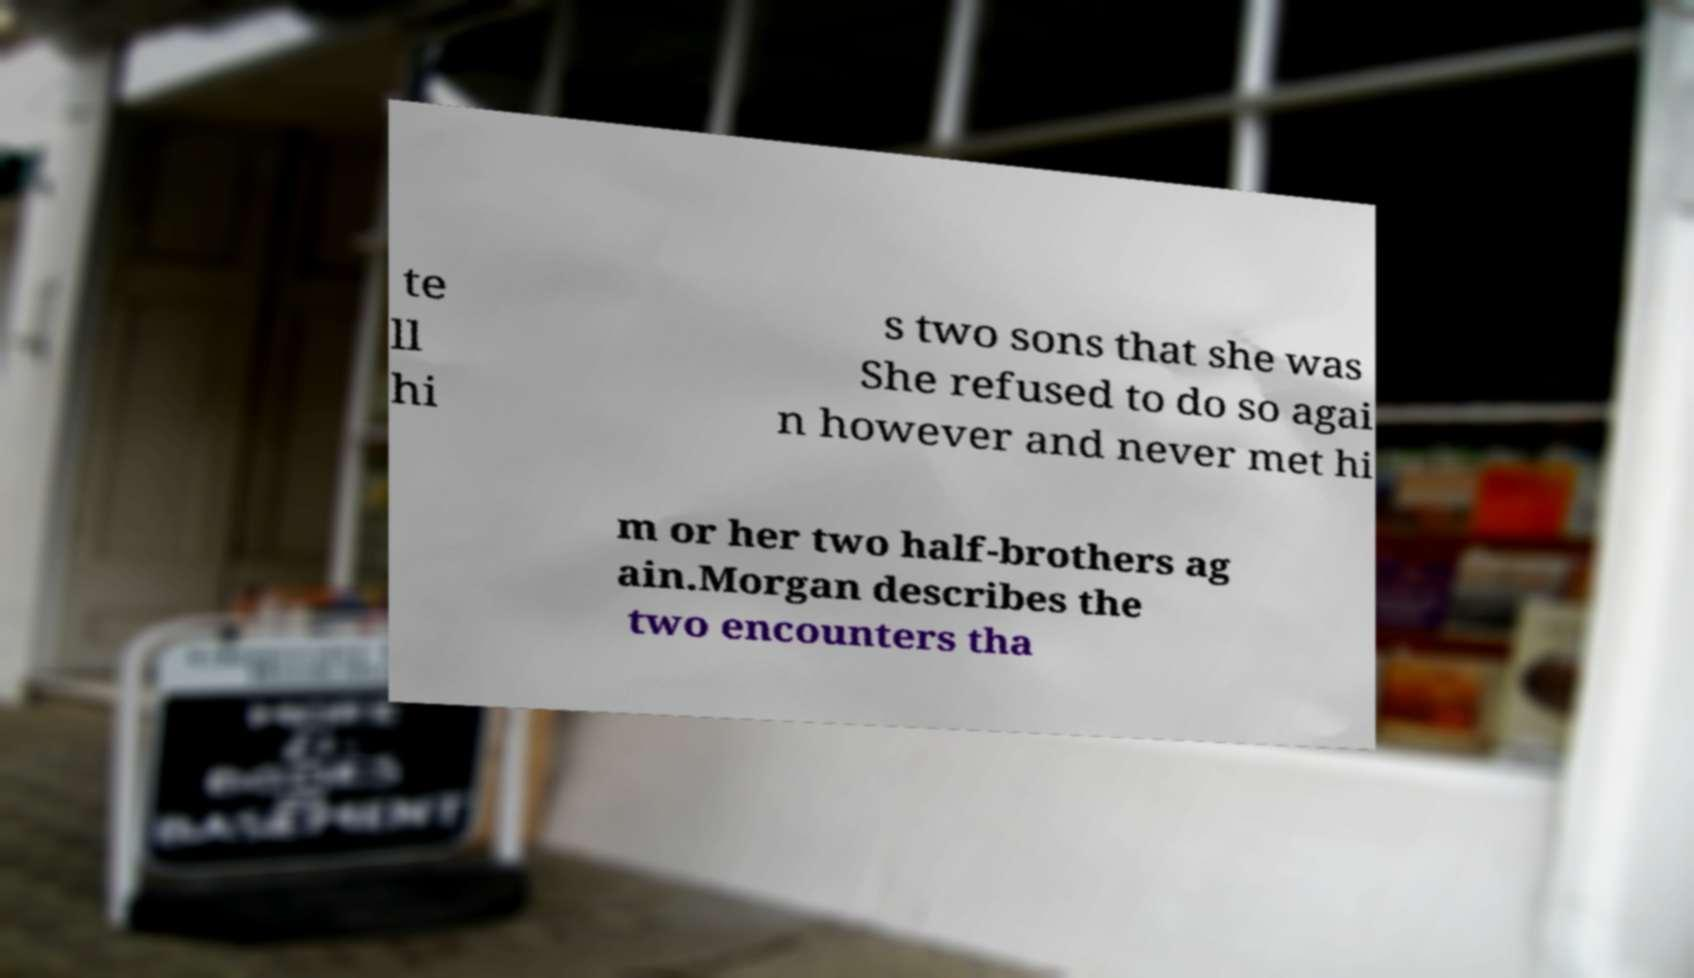Please identify and transcribe the text found in this image. te ll hi s two sons that she was She refused to do so agai n however and never met hi m or her two half-brothers ag ain.Morgan describes the two encounters tha 